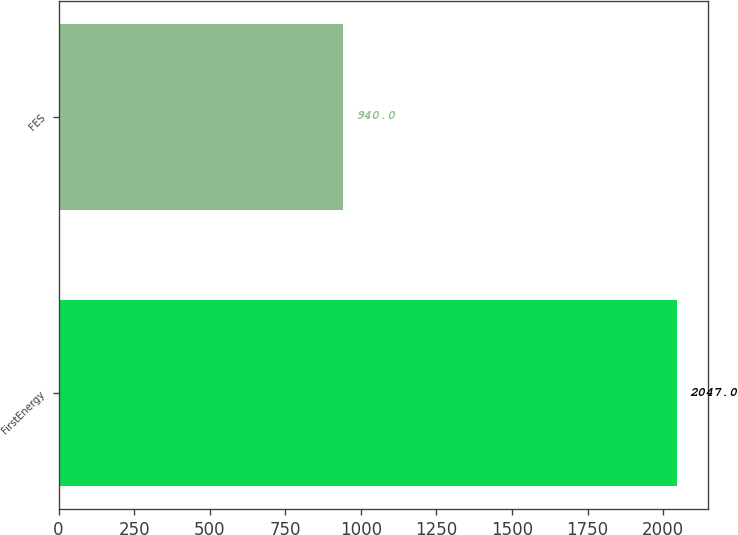Convert chart. <chart><loc_0><loc_0><loc_500><loc_500><bar_chart><fcel>FirstEnergy<fcel>FES<nl><fcel>2047<fcel>940<nl></chart> 